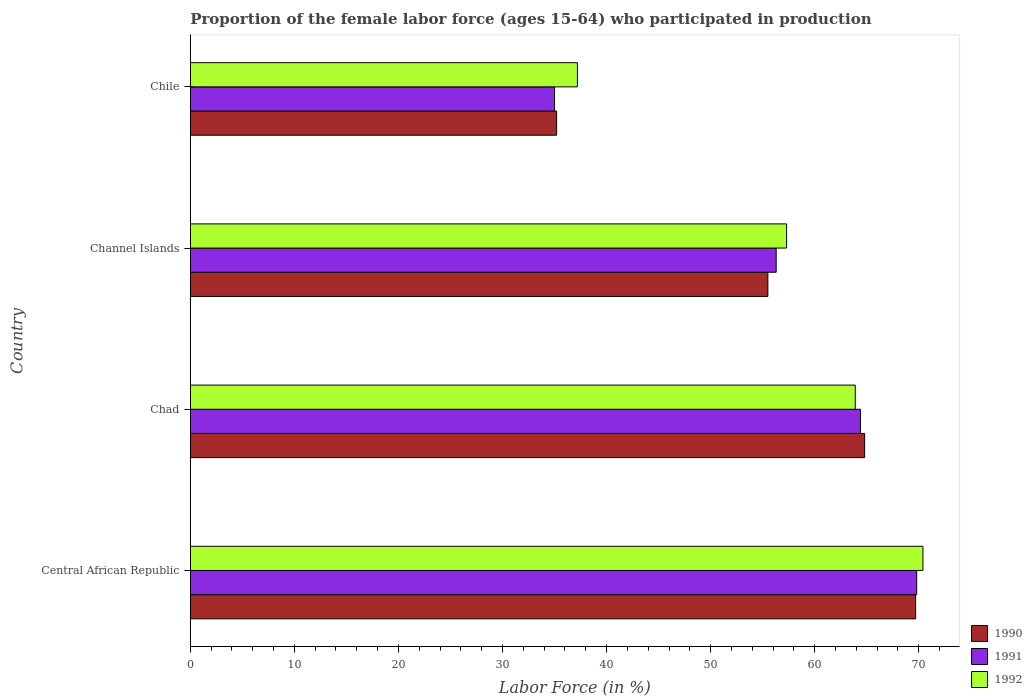How many groups of bars are there?
Offer a very short reply. 4. Are the number of bars per tick equal to the number of legend labels?
Provide a short and direct response. Yes. What is the label of the 1st group of bars from the top?
Offer a terse response. Chile. In how many cases, is the number of bars for a given country not equal to the number of legend labels?
Your answer should be very brief. 0. What is the proportion of the female labor force who participated in production in 1991 in Central African Republic?
Your answer should be very brief. 69.8. Across all countries, what is the maximum proportion of the female labor force who participated in production in 1991?
Ensure brevity in your answer.  69.8. In which country was the proportion of the female labor force who participated in production in 1991 maximum?
Offer a very short reply. Central African Republic. What is the total proportion of the female labor force who participated in production in 1991 in the graph?
Offer a terse response. 225.5. What is the difference between the proportion of the female labor force who participated in production in 1990 in Chad and that in Channel Islands?
Offer a very short reply. 9.3. What is the difference between the proportion of the female labor force who participated in production in 1991 in Central African Republic and the proportion of the female labor force who participated in production in 1992 in Chad?
Ensure brevity in your answer.  5.9. What is the average proportion of the female labor force who participated in production in 1990 per country?
Provide a succinct answer. 56.3. What is the ratio of the proportion of the female labor force who participated in production in 1991 in Central African Republic to that in Chile?
Offer a terse response. 1.99. Is the proportion of the female labor force who participated in production in 1990 in Channel Islands less than that in Chile?
Your answer should be very brief. No. What is the difference between the highest and the second highest proportion of the female labor force who participated in production in 1990?
Offer a terse response. 4.9. What is the difference between the highest and the lowest proportion of the female labor force who participated in production in 1992?
Offer a terse response. 33.2. How many countries are there in the graph?
Give a very brief answer. 4. Are the values on the major ticks of X-axis written in scientific E-notation?
Your answer should be very brief. No. Does the graph contain any zero values?
Your answer should be compact. No. Where does the legend appear in the graph?
Offer a terse response. Bottom right. How are the legend labels stacked?
Your answer should be compact. Vertical. What is the title of the graph?
Give a very brief answer. Proportion of the female labor force (ages 15-64) who participated in production. What is the label or title of the X-axis?
Provide a short and direct response. Labor Force (in %). What is the Labor Force (in %) in 1990 in Central African Republic?
Ensure brevity in your answer.  69.7. What is the Labor Force (in %) in 1991 in Central African Republic?
Your answer should be very brief. 69.8. What is the Labor Force (in %) of 1992 in Central African Republic?
Your answer should be compact. 70.4. What is the Labor Force (in %) of 1990 in Chad?
Your response must be concise. 64.8. What is the Labor Force (in %) of 1991 in Chad?
Make the answer very short. 64.4. What is the Labor Force (in %) of 1992 in Chad?
Offer a terse response. 63.9. What is the Labor Force (in %) in 1990 in Channel Islands?
Keep it short and to the point. 55.5. What is the Labor Force (in %) in 1991 in Channel Islands?
Provide a short and direct response. 56.3. What is the Labor Force (in %) in 1992 in Channel Islands?
Offer a very short reply. 57.3. What is the Labor Force (in %) of 1990 in Chile?
Ensure brevity in your answer.  35.2. What is the Labor Force (in %) of 1992 in Chile?
Provide a short and direct response. 37.2. Across all countries, what is the maximum Labor Force (in %) of 1990?
Offer a very short reply. 69.7. Across all countries, what is the maximum Labor Force (in %) of 1991?
Your response must be concise. 69.8. Across all countries, what is the maximum Labor Force (in %) of 1992?
Offer a terse response. 70.4. Across all countries, what is the minimum Labor Force (in %) in 1990?
Your answer should be compact. 35.2. Across all countries, what is the minimum Labor Force (in %) in 1991?
Offer a very short reply. 35. Across all countries, what is the minimum Labor Force (in %) in 1992?
Provide a succinct answer. 37.2. What is the total Labor Force (in %) of 1990 in the graph?
Offer a terse response. 225.2. What is the total Labor Force (in %) in 1991 in the graph?
Provide a succinct answer. 225.5. What is the total Labor Force (in %) of 1992 in the graph?
Provide a succinct answer. 228.8. What is the difference between the Labor Force (in %) of 1992 in Central African Republic and that in Channel Islands?
Offer a terse response. 13.1. What is the difference between the Labor Force (in %) in 1990 in Central African Republic and that in Chile?
Offer a terse response. 34.5. What is the difference between the Labor Force (in %) in 1991 in Central African Republic and that in Chile?
Your response must be concise. 34.8. What is the difference between the Labor Force (in %) of 1992 in Central African Republic and that in Chile?
Keep it short and to the point. 33.2. What is the difference between the Labor Force (in %) of 1990 in Chad and that in Channel Islands?
Your response must be concise. 9.3. What is the difference between the Labor Force (in %) of 1991 in Chad and that in Channel Islands?
Your response must be concise. 8.1. What is the difference between the Labor Force (in %) in 1992 in Chad and that in Channel Islands?
Provide a short and direct response. 6.6. What is the difference between the Labor Force (in %) of 1990 in Chad and that in Chile?
Keep it short and to the point. 29.6. What is the difference between the Labor Force (in %) in 1991 in Chad and that in Chile?
Provide a short and direct response. 29.4. What is the difference between the Labor Force (in %) of 1992 in Chad and that in Chile?
Ensure brevity in your answer.  26.7. What is the difference between the Labor Force (in %) in 1990 in Channel Islands and that in Chile?
Give a very brief answer. 20.3. What is the difference between the Labor Force (in %) in 1991 in Channel Islands and that in Chile?
Offer a terse response. 21.3. What is the difference between the Labor Force (in %) of 1992 in Channel Islands and that in Chile?
Your response must be concise. 20.1. What is the difference between the Labor Force (in %) in 1991 in Central African Republic and the Labor Force (in %) in 1992 in Chad?
Ensure brevity in your answer.  5.9. What is the difference between the Labor Force (in %) of 1990 in Central African Republic and the Labor Force (in %) of 1991 in Chile?
Provide a succinct answer. 34.7. What is the difference between the Labor Force (in %) of 1990 in Central African Republic and the Labor Force (in %) of 1992 in Chile?
Your response must be concise. 32.5. What is the difference between the Labor Force (in %) in 1991 in Central African Republic and the Labor Force (in %) in 1992 in Chile?
Provide a short and direct response. 32.6. What is the difference between the Labor Force (in %) of 1990 in Chad and the Labor Force (in %) of 1992 in Channel Islands?
Provide a short and direct response. 7.5. What is the difference between the Labor Force (in %) of 1990 in Chad and the Labor Force (in %) of 1991 in Chile?
Your answer should be very brief. 29.8. What is the difference between the Labor Force (in %) of 1990 in Chad and the Labor Force (in %) of 1992 in Chile?
Ensure brevity in your answer.  27.6. What is the difference between the Labor Force (in %) in 1991 in Chad and the Labor Force (in %) in 1992 in Chile?
Offer a very short reply. 27.2. What is the difference between the Labor Force (in %) in 1990 in Channel Islands and the Labor Force (in %) in 1992 in Chile?
Keep it short and to the point. 18.3. What is the difference between the Labor Force (in %) in 1991 in Channel Islands and the Labor Force (in %) in 1992 in Chile?
Keep it short and to the point. 19.1. What is the average Labor Force (in %) in 1990 per country?
Offer a terse response. 56.3. What is the average Labor Force (in %) in 1991 per country?
Ensure brevity in your answer.  56.38. What is the average Labor Force (in %) of 1992 per country?
Your answer should be very brief. 57.2. What is the difference between the Labor Force (in %) of 1991 and Labor Force (in %) of 1992 in Chad?
Offer a very short reply. 0.5. What is the difference between the Labor Force (in %) in 1990 and Labor Force (in %) in 1992 in Chile?
Your answer should be compact. -2. What is the ratio of the Labor Force (in %) in 1990 in Central African Republic to that in Chad?
Keep it short and to the point. 1.08. What is the ratio of the Labor Force (in %) of 1991 in Central African Republic to that in Chad?
Your response must be concise. 1.08. What is the ratio of the Labor Force (in %) of 1992 in Central African Republic to that in Chad?
Provide a short and direct response. 1.1. What is the ratio of the Labor Force (in %) of 1990 in Central African Republic to that in Channel Islands?
Your answer should be very brief. 1.26. What is the ratio of the Labor Force (in %) in 1991 in Central African Republic to that in Channel Islands?
Give a very brief answer. 1.24. What is the ratio of the Labor Force (in %) of 1992 in Central African Republic to that in Channel Islands?
Give a very brief answer. 1.23. What is the ratio of the Labor Force (in %) in 1990 in Central African Republic to that in Chile?
Your answer should be compact. 1.98. What is the ratio of the Labor Force (in %) of 1991 in Central African Republic to that in Chile?
Offer a very short reply. 1.99. What is the ratio of the Labor Force (in %) in 1992 in Central African Republic to that in Chile?
Keep it short and to the point. 1.89. What is the ratio of the Labor Force (in %) in 1990 in Chad to that in Channel Islands?
Offer a terse response. 1.17. What is the ratio of the Labor Force (in %) in 1991 in Chad to that in Channel Islands?
Offer a very short reply. 1.14. What is the ratio of the Labor Force (in %) in 1992 in Chad to that in Channel Islands?
Your response must be concise. 1.12. What is the ratio of the Labor Force (in %) of 1990 in Chad to that in Chile?
Ensure brevity in your answer.  1.84. What is the ratio of the Labor Force (in %) of 1991 in Chad to that in Chile?
Provide a short and direct response. 1.84. What is the ratio of the Labor Force (in %) of 1992 in Chad to that in Chile?
Your answer should be very brief. 1.72. What is the ratio of the Labor Force (in %) of 1990 in Channel Islands to that in Chile?
Keep it short and to the point. 1.58. What is the ratio of the Labor Force (in %) of 1991 in Channel Islands to that in Chile?
Keep it short and to the point. 1.61. What is the ratio of the Labor Force (in %) of 1992 in Channel Islands to that in Chile?
Provide a short and direct response. 1.54. What is the difference between the highest and the second highest Labor Force (in %) of 1990?
Your response must be concise. 4.9. What is the difference between the highest and the second highest Labor Force (in %) of 1991?
Ensure brevity in your answer.  5.4. What is the difference between the highest and the lowest Labor Force (in %) in 1990?
Keep it short and to the point. 34.5. What is the difference between the highest and the lowest Labor Force (in %) of 1991?
Your response must be concise. 34.8. What is the difference between the highest and the lowest Labor Force (in %) in 1992?
Provide a succinct answer. 33.2. 